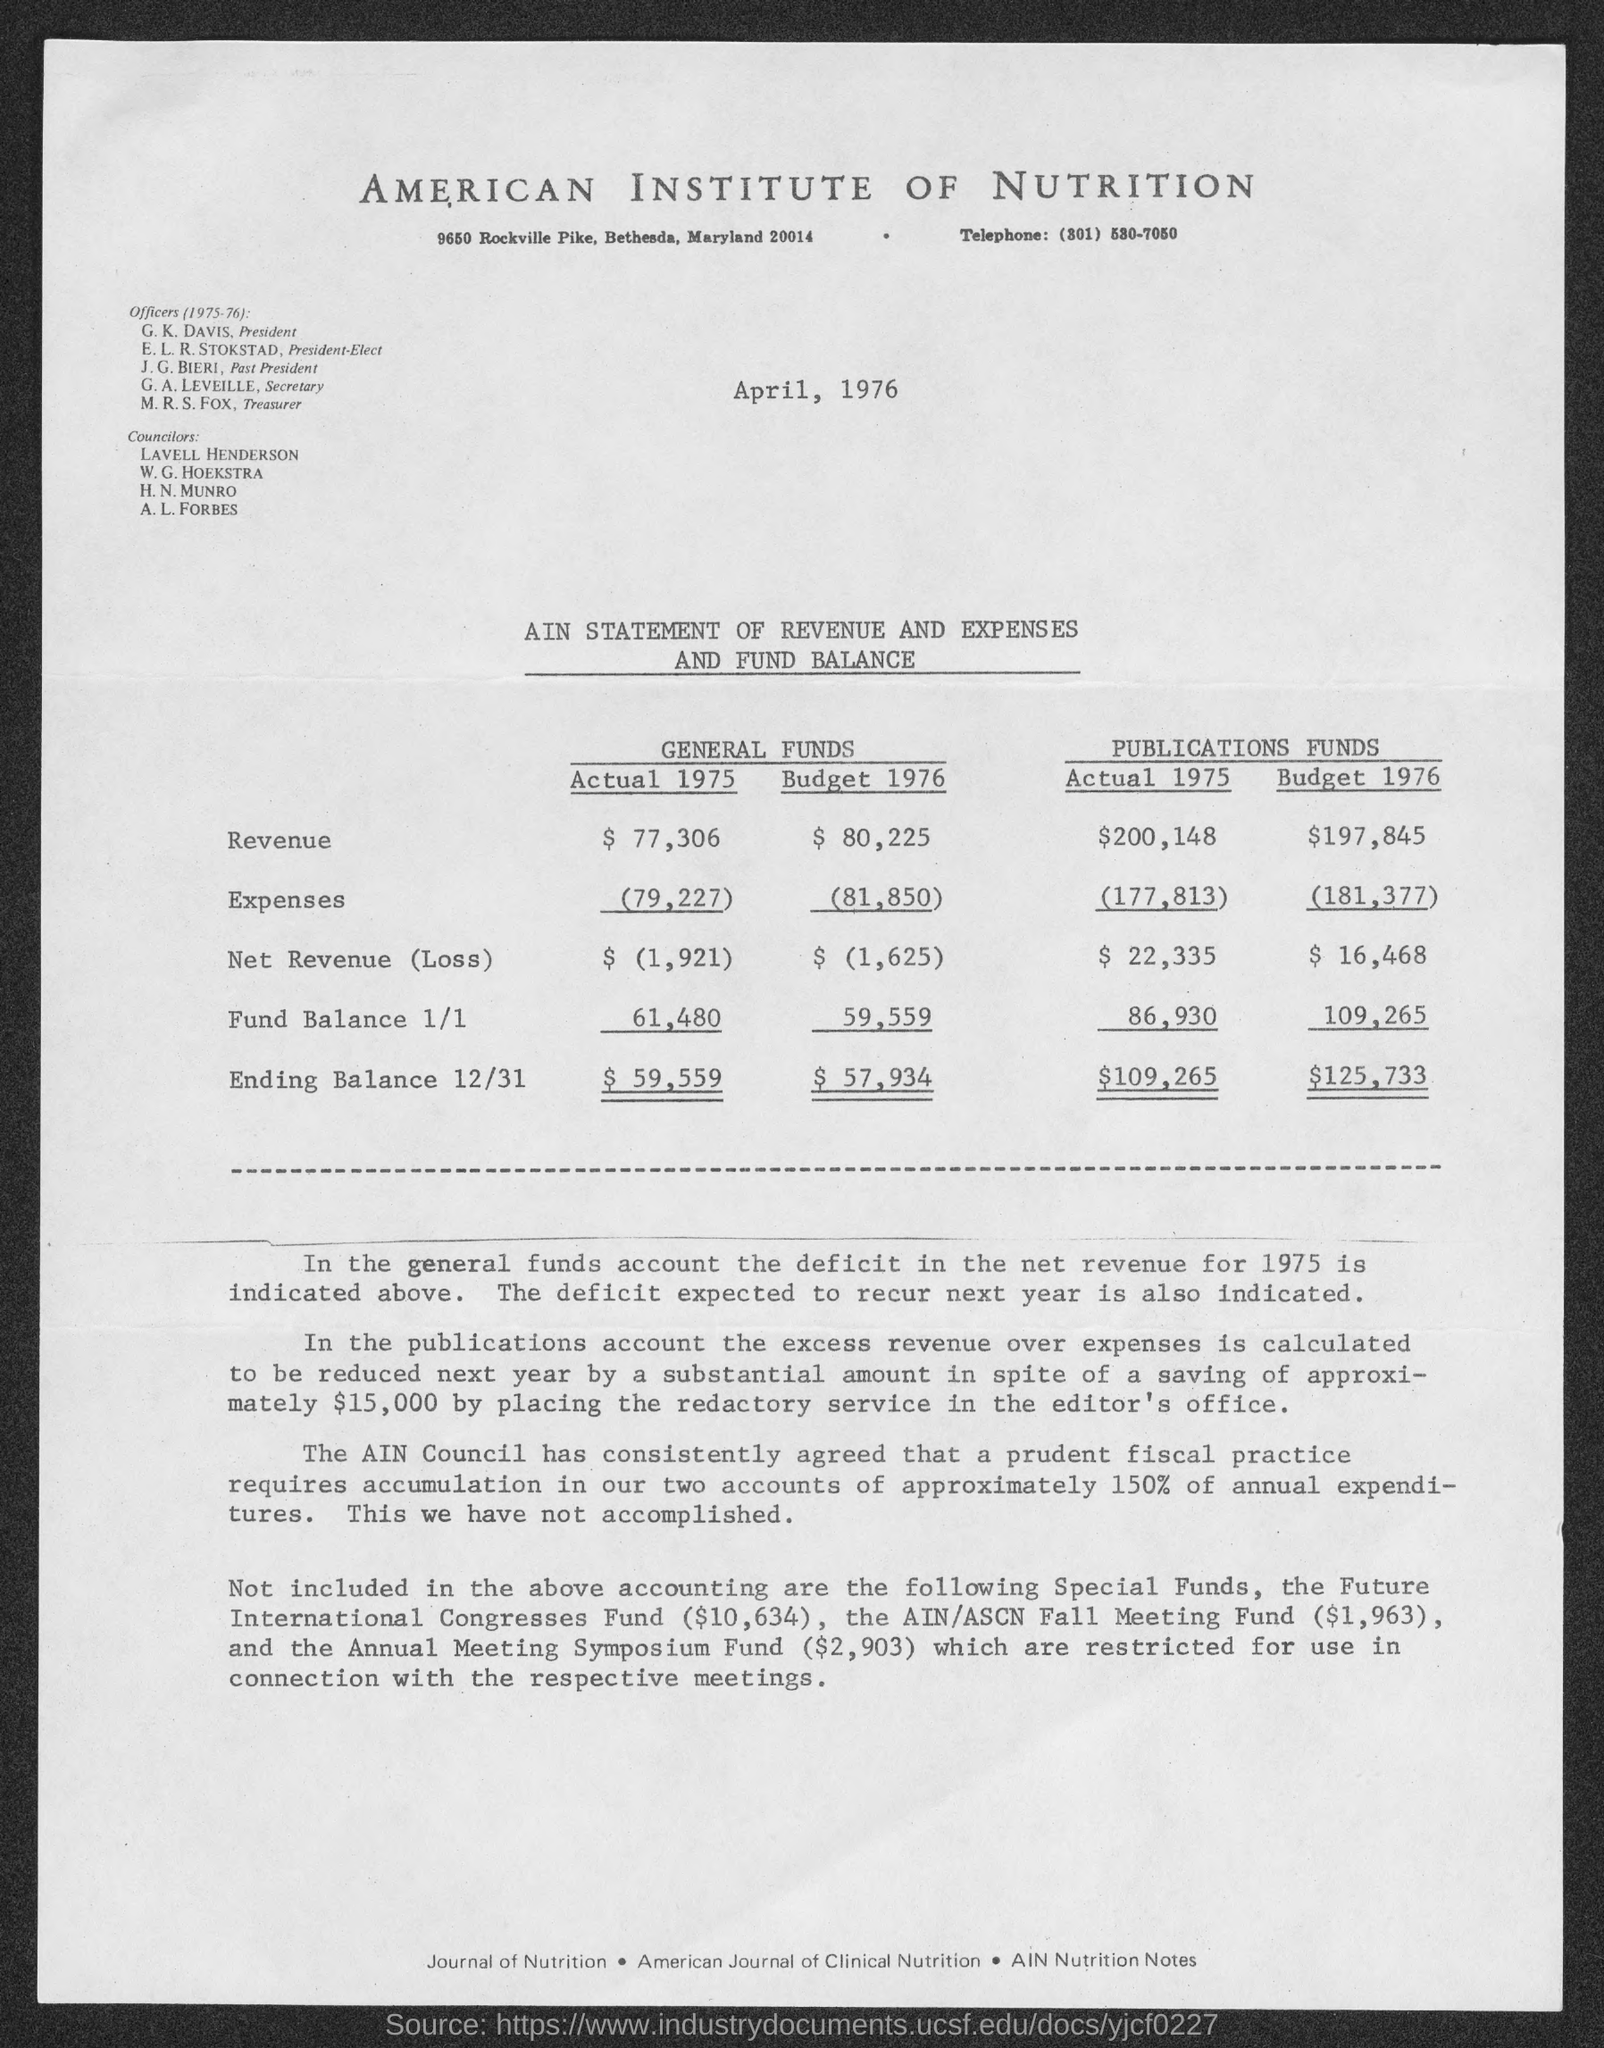What is the title of the document?
Make the answer very short. American Institute of Nutrition. What is the date mentioned in the document?
Ensure brevity in your answer.  April, 1976. 